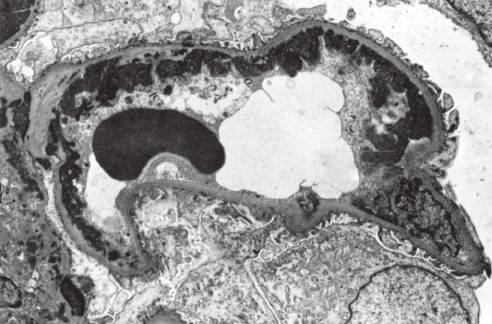does methylation of particular histone residues correspond to wire loops seen by light microscopy?
Answer the question using a single word or phrase. No 